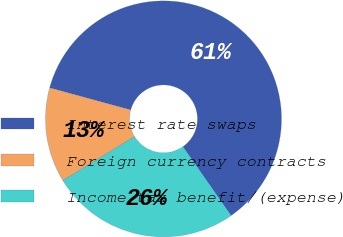<chart> <loc_0><loc_0><loc_500><loc_500><pie_chart><fcel>Interest rate swaps<fcel>Foreign currency contracts<fcel>Income tax benefit/(expense)<nl><fcel>61.04%<fcel>12.99%<fcel>25.97%<nl></chart> 